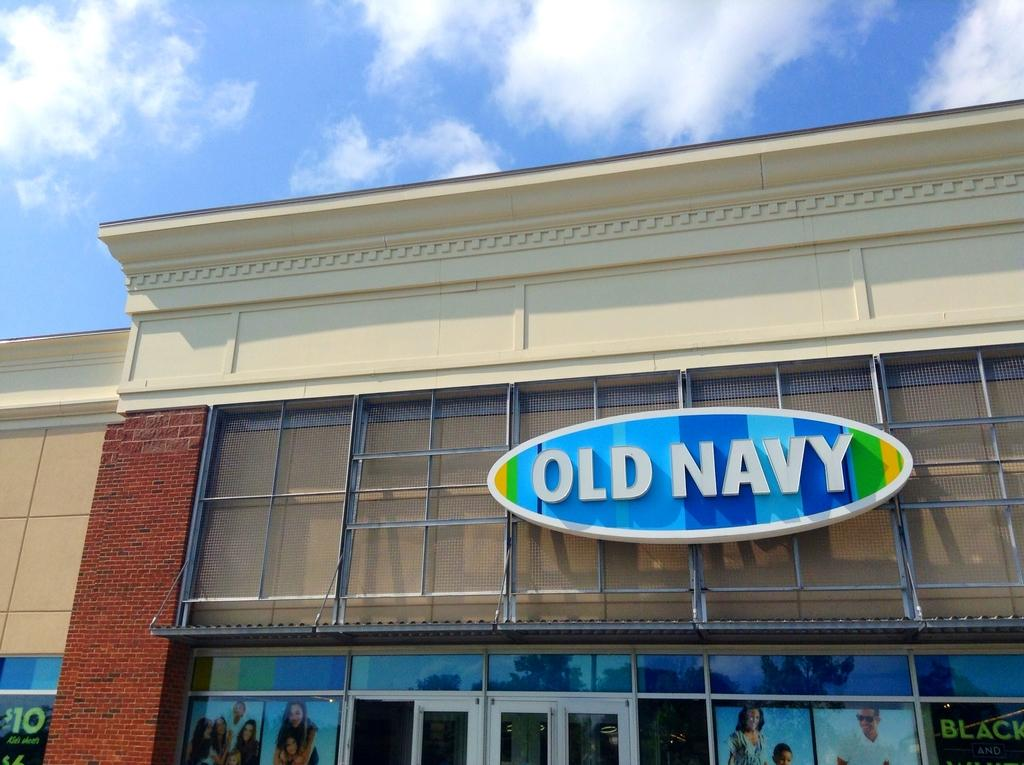What can be seen in the sky in the image? The sky with clouds is visible in the image. What type of structures are present in the image? There are buildings in the image. What sign or board is present in the image? A name board is present in the image. Where are advertisements displayed in the image? Advertisements are displayed on mirrors in the image. What type of company is represented by the apple in the image? There is no apple present in the image, so it is not possible to determine the type of company it might represent. 